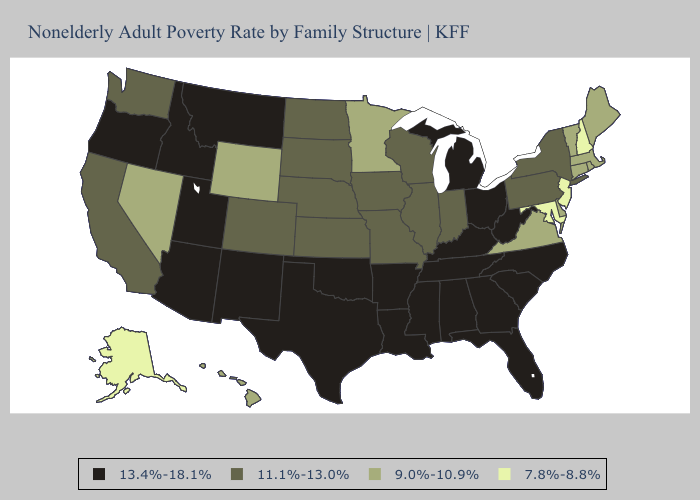Among the states that border Florida , which have the lowest value?
Short answer required. Alabama, Georgia. What is the lowest value in states that border Kentucky?
Concise answer only. 9.0%-10.9%. Name the states that have a value in the range 7.8%-8.8%?
Give a very brief answer. Alaska, Maryland, New Hampshire, New Jersey. What is the lowest value in states that border Wyoming?
Write a very short answer. 11.1%-13.0%. Name the states that have a value in the range 11.1%-13.0%?
Keep it brief. California, Colorado, Illinois, Indiana, Iowa, Kansas, Missouri, Nebraska, New York, North Dakota, Pennsylvania, South Dakota, Washington, Wisconsin. Does Wisconsin have the highest value in the USA?
Be succinct. No. What is the value of West Virginia?
Write a very short answer. 13.4%-18.1%. Name the states that have a value in the range 9.0%-10.9%?
Answer briefly. Connecticut, Delaware, Hawaii, Maine, Massachusetts, Minnesota, Nevada, Rhode Island, Vermont, Virginia, Wyoming. Name the states that have a value in the range 11.1%-13.0%?
Keep it brief. California, Colorado, Illinois, Indiana, Iowa, Kansas, Missouri, Nebraska, New York, North Dakota, Pennsylvania, South Dakota, Washington, Wisconsin. Name the states that have a value in the range 11.1%-13.0%?
Be succinct. California, Colorado, Illinois, Indiana, Iowa, Kansas, Missouri, Nebraska, New York, North Dakota, Pennsylvania, South Dakota, Washington, Wisconsin. Among the states that border North Dakota , which have the lowest value?
Concise answer only. Minnesota. What is the highest value in states that border Kansas?
Quick response, please. 13.4%-18.1%. What is the highest value in states that border Illinois?
Short answer required. 13.4%-18.1%. Name the states that have a value in the range 7.8%-8.8%?
Give a very brief answer. Alaska, Maryland, New Hampshire, New Jersey. Name the states that have a value in the range 7.8%-8.8%?
Answer briefly. Alaska, Maryland, New Hampshire, New Jersey. 